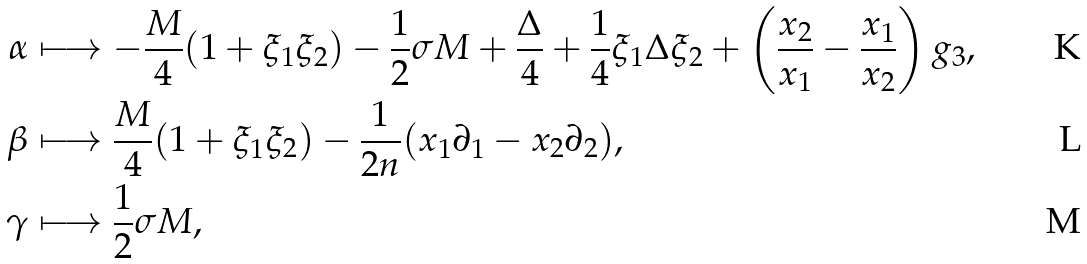Convert formula to latex. <formula><loc_0><loc_0><loc_500><loc_500>\alpha & \longmapsto - \frac { M } { 4 } ( 1 + \xi _ { 1 } \xi _ { 2 } ) - \frac { 1 } { 2 } \sigma M + \frac { \Delta } { 4 } + \frac { 1 } { 4 } \xi _ { 1 } \Delta \xi _ { 2 } + \left ( \frac { x _ { 2 } } { x _ { 1 } } - \frac { x _ { 1 } } { x _ { 2 } } \right ) g _ { 3 } , \\ \beta & \longmapsto \frac { M } { 4 } ( 1 + \xi _ { 1 } \xi _ { 2 } ) - \frac { 1 } { 2 n } ( x _ { 1 } \partial _ { 1 } - x _ { 2 } \partial _ { 2 } ) , \\ \gamma & \longmapsto \frac { 1 } { 2 } \sigma M ,</formula> 